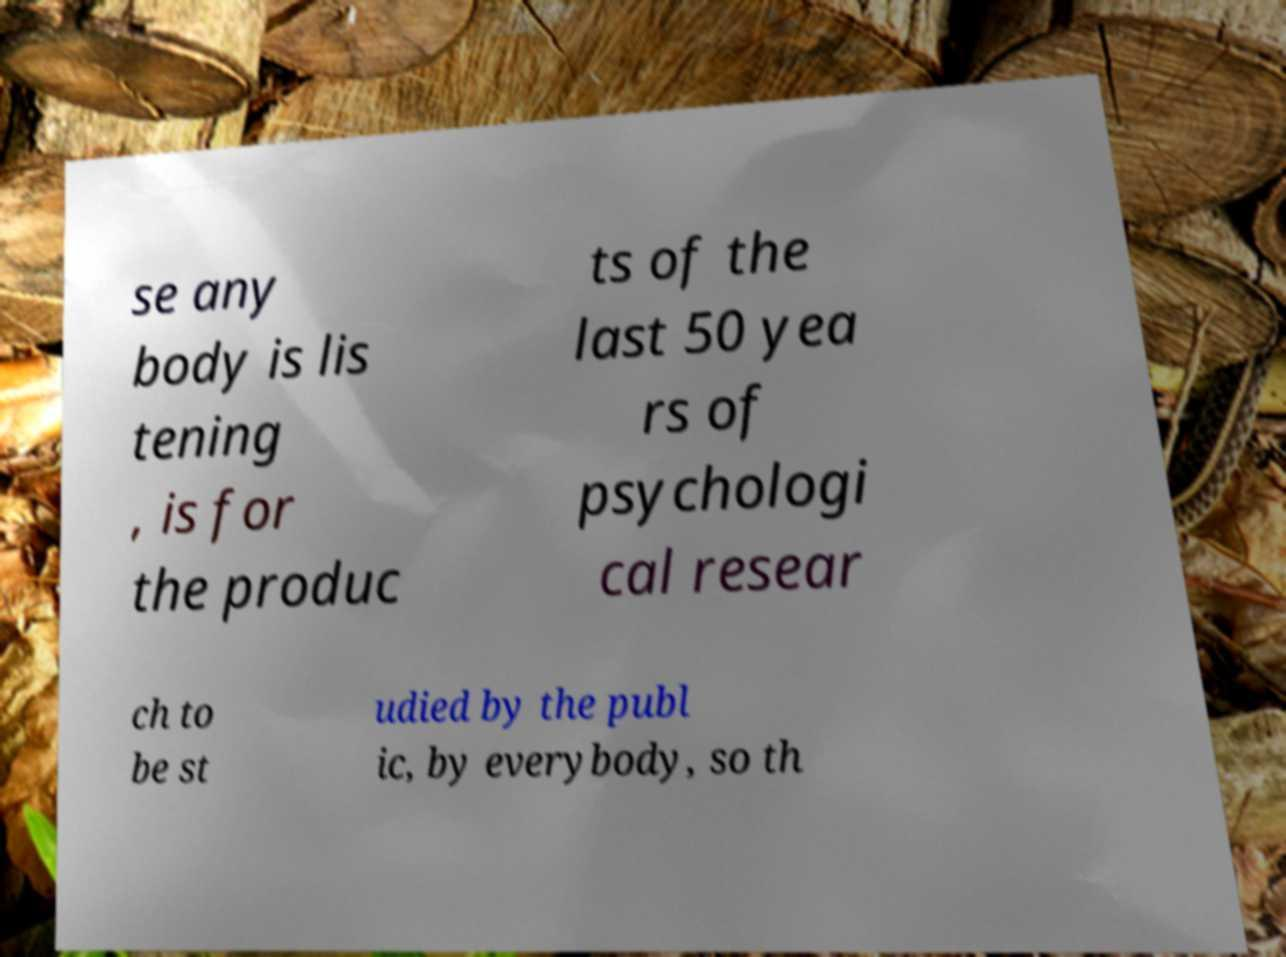Could you assist in decoding the text presented in this image and type it out clearly? se any body is lis tening , is for the produc ts of the last 50 yea rs of psychologi cal resear ch to be st udied by the publ ic, by everybody, so th 